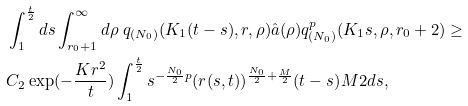<formula> <loc_0><loc_0><loc_500><loc_500>& \int _ { 1 } ^ { \frac { t } { 2 } } d s \int _ { r _ { 0 } + 1 } ^ { \infty } d \rho \ q _ { ( N _ { 0 } ) } ( K _ { 1 } ( t - s ) , r , \rho ) \hat { a } ( \rho ) q ^ { p } _ { ( N _ { 0 } ) } ( K _ { 1 } s , \rho , r _ { 0 } + 2 ) \geq \\ & C _ { 2 } \exp ( - \frac { K r ^ { 2 } } t ) \int _ { 1 } ^ { \frac { t } { 2 } } s ^ { - \frac { N _ { 0 } } 2 p } ( r ( s , t ) ) ^ { \frac { N _ { 0 } } 2 + \frac { M } { 2 } } ( t - s ) ^ { } { M } 2 d s ,</formula> 